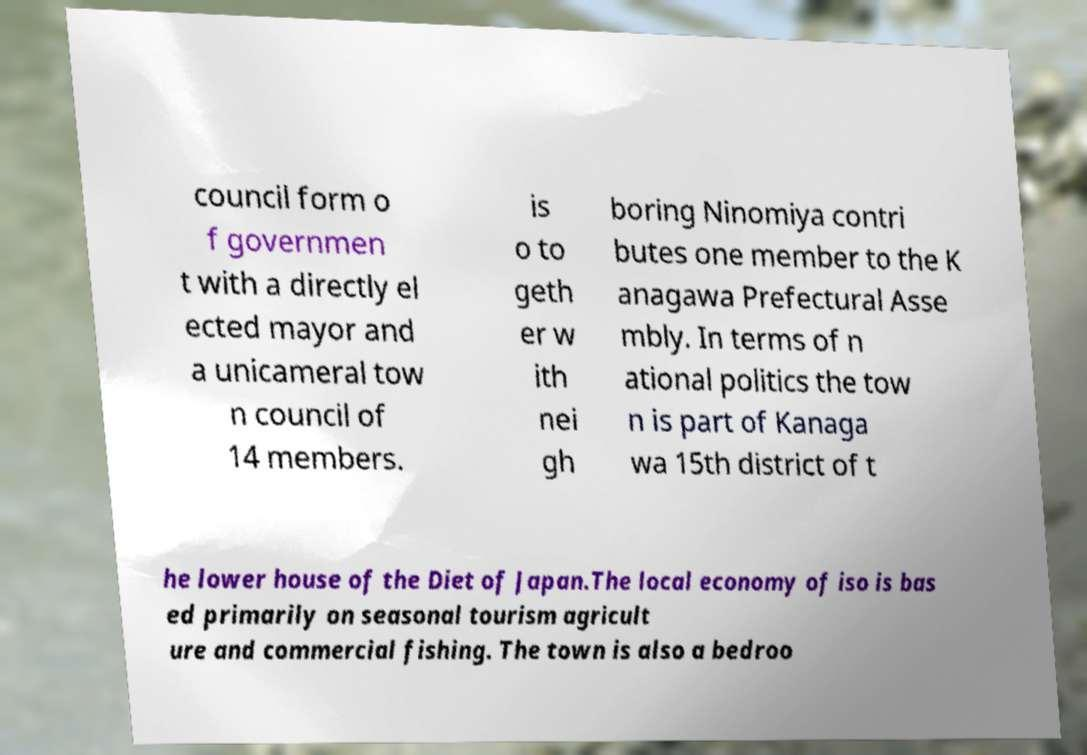Could you assist in decoding the text presented in this image and type it out clearly? council form o f governmen t with a directly el ected mayor and a unicameral tow n council of 14 members. is o to geth er w ith nei gh boring Ninomiya contri butes one member to the K anagawa Prefectural Asse mbly. In terms of n ational politics the tow n is part of Kanaga wa 15th district of t he lower house of the Diet of Japan.The local economy of iso is bas ed primarily on seasonal tourism agricult ure and commercial fishing. The town is also a bedroo 